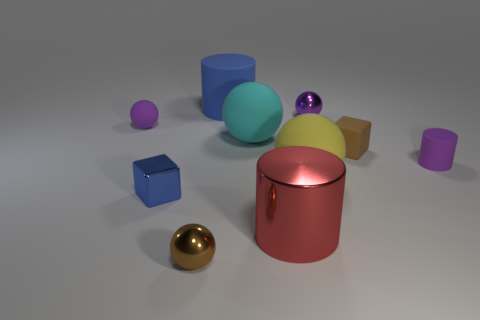Which objects in the image could roll if placed on a slope? The spherical objects, specifically the small rubber sphere and the larger turquoise ball, could roll if placed on a slope due to their perfectly round shapes. The smaller purple sphere could also roll, albeit with less stability. 